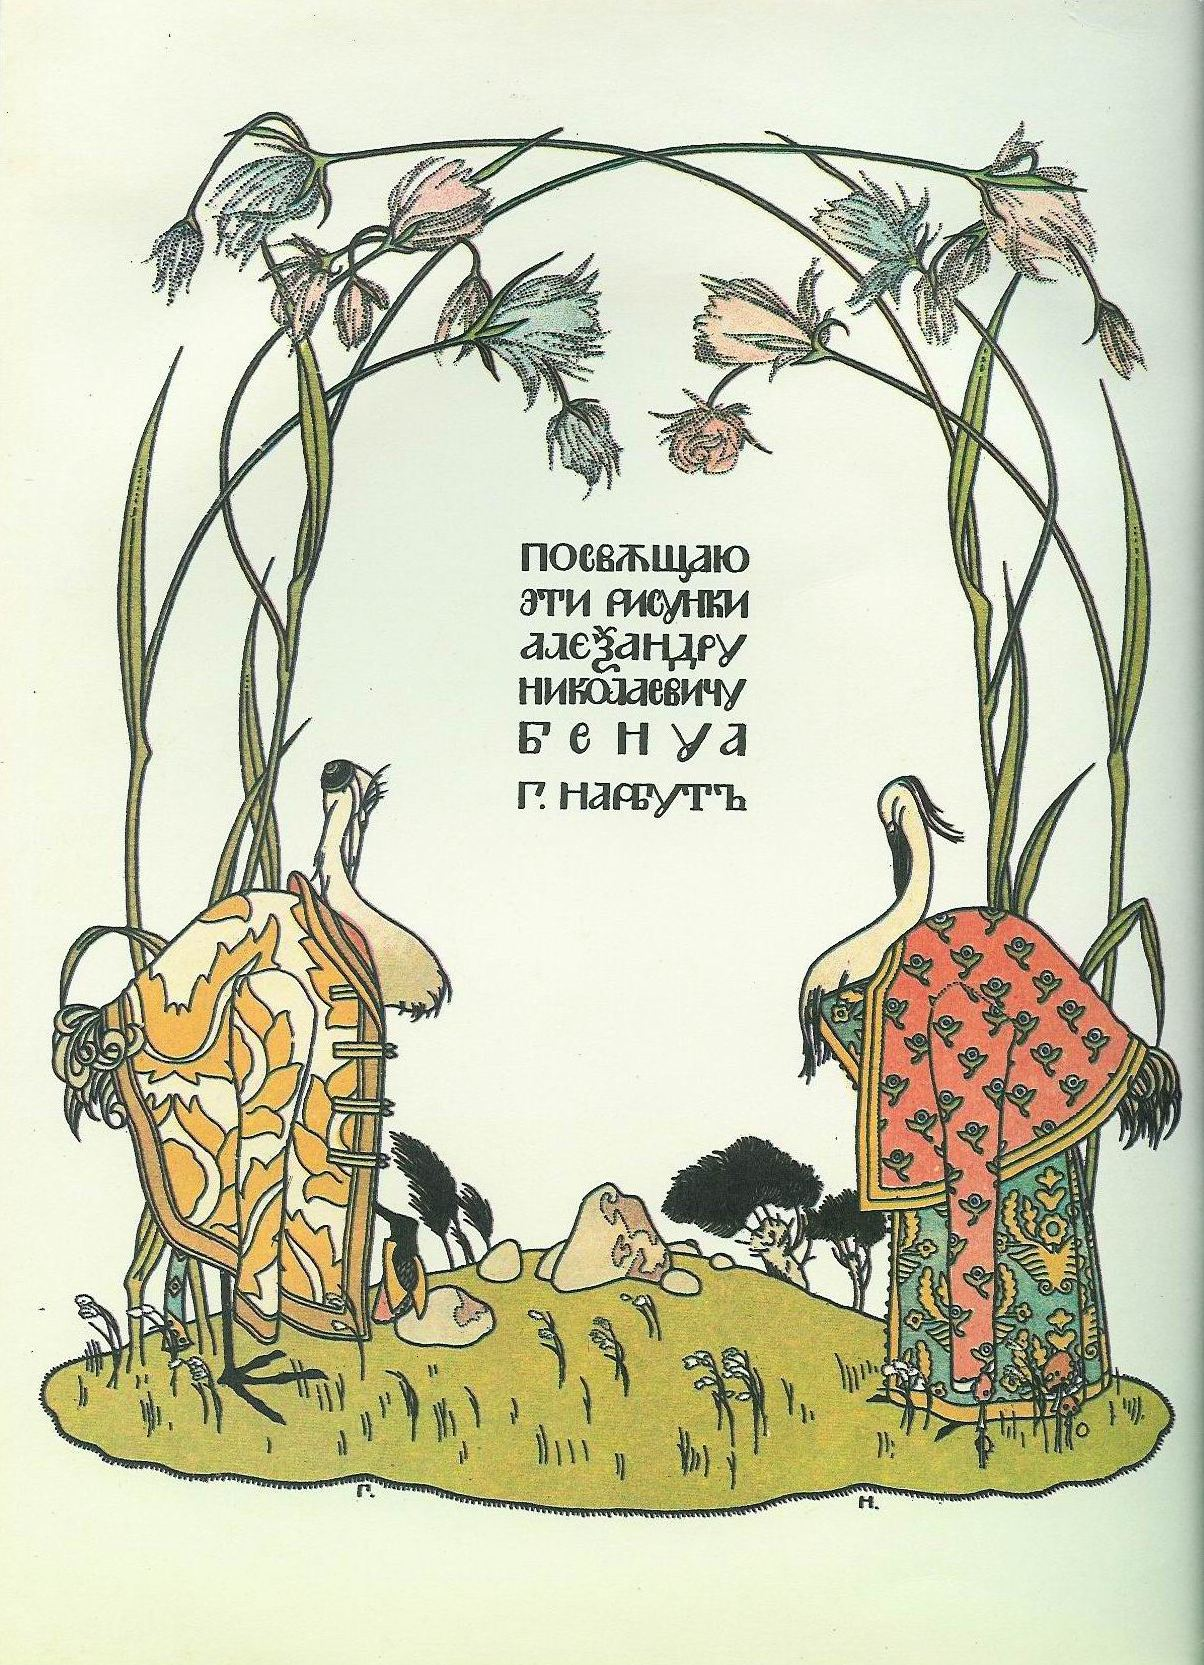How does the art style contribute to the overall feel of the image? The Art Nouveau style of the illustration significantly contributes to the image's enchanting and harmonious feel. Characterized by its fluid lines, organic forms, and intricate patterns, this artistic approach creates a seamless integration of nature and design. The gentle curvature of the stems, the delicate rendering of the flowers, and the elegant attire of the storks all evoke a sense of timeless beauty and tranquil elegance. The pale green background further enhances the image's serene and mystical atmosphere, inviting viewers into a world where art and nature coexist in perfect harmony. What could the text in the middle signify? The text in the middle of the image appears to be a dedication or an inscription, possibly contextualizing the artwork within a larger narrative or cultural tradition. It might be a dedication to a significant figure, an acknowledgment of the artist, or a poetic phrase that enhances the fairy-tale quality of the scene. This text, framed by the graceful archway, ties together the visual and written elements, enriching the narrative and providing a deeper layer of meaning to the illustration. Imagine this image as part of an animated story. What would be the plot? In an enchanted forest, two ancient storks, Sir Featherington and Lady Plummewing, serve as the wise guardians of the Land of Wishes, a magical realm where dreams come to life. Each year, villagers from far and wide travel to their mystical garden, leaving behind flowers imbued with their deepest wishes. The storks, dressed in their royal garments, use their ancient wisdom and gentle magic to nurture these flowers, bringing the heartfelt dreams of the people into reality. One day, a dark cloud of sorrow threatens the land, caused by a formidable sorcerer who has lost faith in dreams. A brave young girl named Elara, guided by the enchanting beauty of the garden and the wisdom of the storks, embarks on a quest to restore hope and harmony. Along her journey, she learns the true power of dreams and courage, forging friendships and uncovering secrets of the magical world. The story culminates in a heartfelt confrontation where Elara, with the help of Sir Featherington and Lady Plummewing, reignites the sorcerer's lost dreams, restoring peace and wonder to the land. 